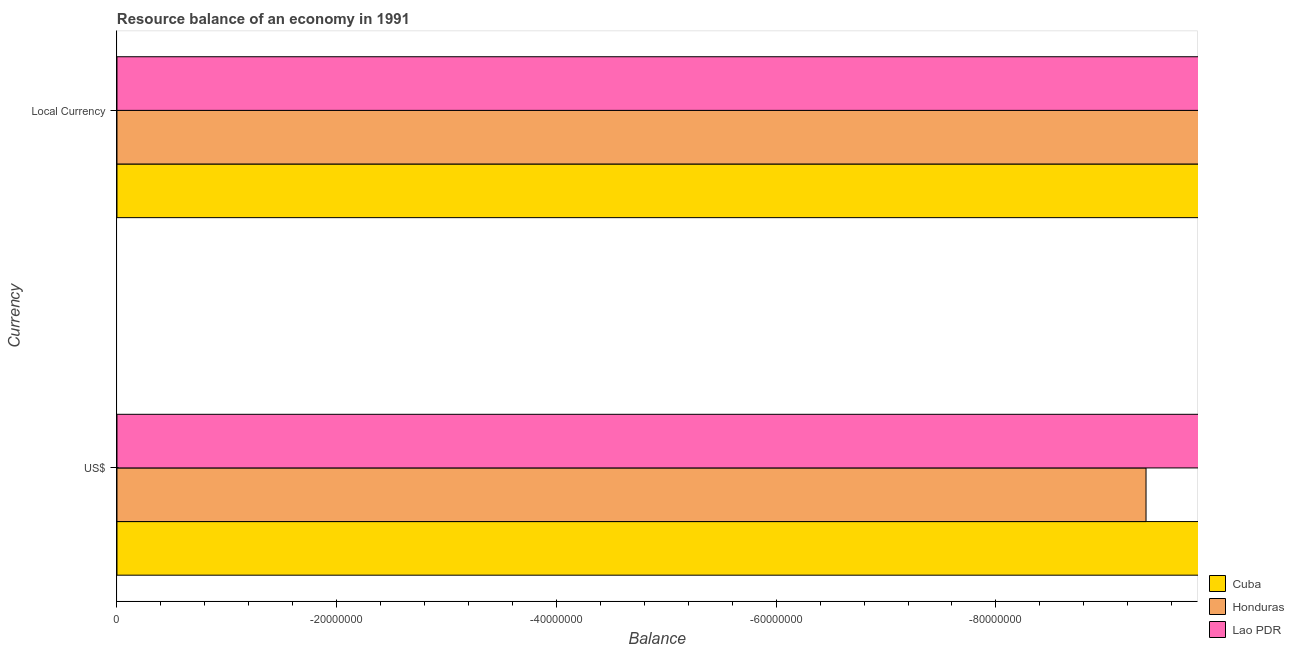How many different coloured bars are there?
Keep it short and to the point. 0. Are the number of bars on each tick of the Y-axis equal?
Offer a terse response. Yes. How many bars are there on the 1st tick from the top?
Offer a very short reply. 0. What is the label of the 1st group of bars from the top?
Ensure brevity in your answer.  Local Currency. Across all countries, what is the minimum resource balance in us$?
Provide a succinct answer. 0. In how many countries, is the resource balance in constant us$ greater than the average resource balance in constant us$ taken over all countries?
Offer a terse response. 0. How many bars are there?
Give a very brief answer. 0. How many countries are there in the graph?
Ensure brevity in your answer.  3. Does the graph contain grids?
Offer a very short reply. No. Where does the legend appear in the graph?
Keep it short and to the point. Bottom right. How are the legend labels stacked?
Offer a very short reply. Vertical. What is the title of the graph?
Ensure brevity in your answer.  Resource balance of an economy in 1991. Does "Equatorial Guinea" appear as one of the legend labels in the graph?
Provide a succinct answer. No. What is the label or title of the X-axis?
Your answer should be very brief. Balance. What is the label or title of the Y-axis?
Offer a terse response. Currency. What is the Balance of Cuba in US$?
Keep it short and to the point. 0. What is the Balance in Cuba in Local Currency?
Keep it short and to the point. 0. What is the Balance in Honduras in Local Currency?
Offer a terse response. 0. What is the total Balance in Cuba in the graph?
Your answer should be very brief. 0. What is the total Balance of Honduras in the graph?
Give a very brief answer. 0. What is the average Balance in Lao PDR per Currency?
Keep it short and to the point. 0. 